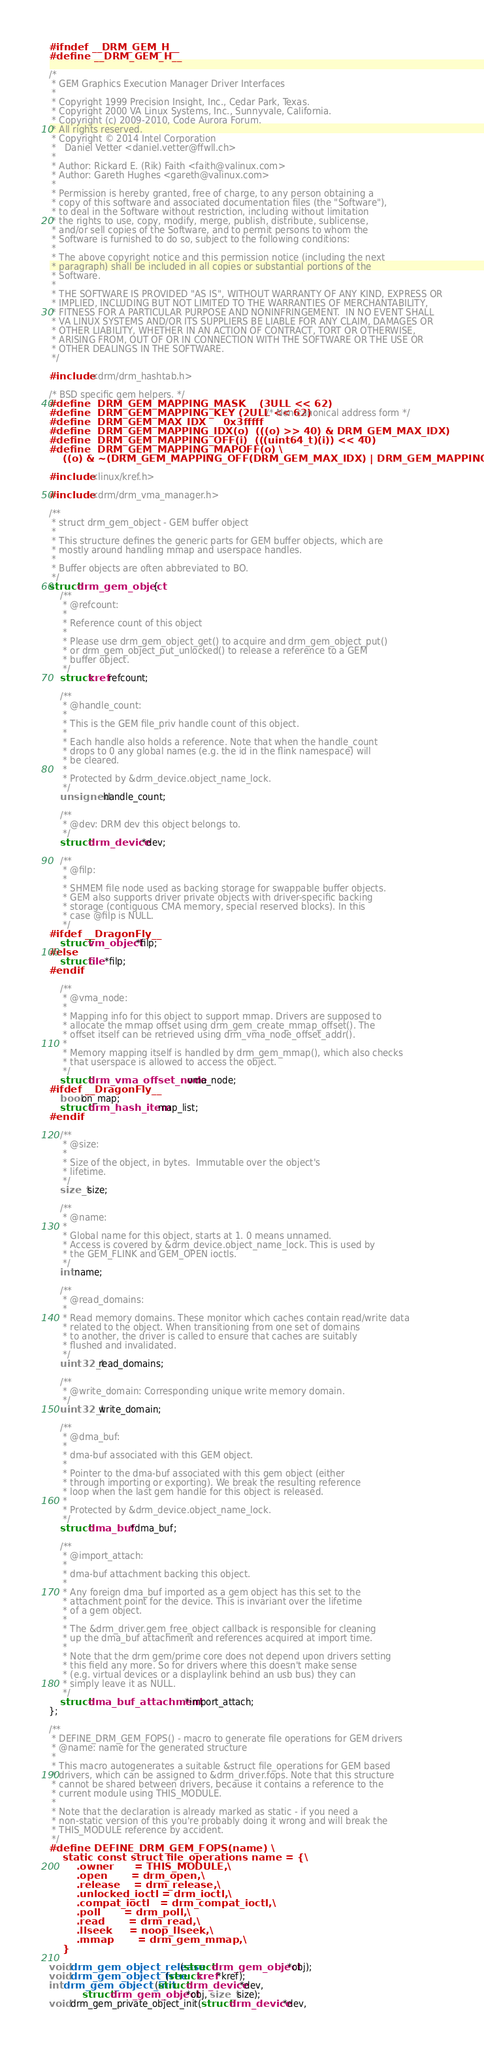<code> <loc_0><loc_0><loc_500><loc_500><_C_>#ifndef __DRM_GEM_H__
#define __DRM_GEM_H__

/*
 * GEM Graphics Execution Manager Driver Interfaces
 *
 * Copyright 1999 Precision Insight, Inc., Cedar Park, Texas.
 * Copyright 2000 VA Linux Systems, Inc., Sunnyvale, California.
 * Copyright (c) 2009-2010, Code Aurora Forum.
 * All rights reserved.
 * Copyright © 2014 Intel Corporation
 *   Daniel Vetter <daniel.vetter@ffwll.ch>
 *
 * Author: Rickard E. (Rik) Faith <faith@valinux.com>
 * Author: Gareth Hughes <gareth@valinux.com>
 *
 * Permission is hereby granted, free of charge, to any person obtaining a
 * copy of this software and associated documentation files (the "Software"),
 * to deal in the Software without restriction, including without limitation
 * the rights to use, copy, modify, merge, publish, distribute, sublicense,
 * and/or sell copies of the Software, and to permit persons to whom the
 * Software is furnished to do so, subject to the following conditions:
 *
 * The above copyright notice and this permission notice (including the next
 * paragraph) shall be included in all copies or substantial portions of the
 * Software.
 *
 * THE SOFTWARE IS PROVIDED "AS IS", WITHOUT WARRANTY OF ANY KIND, EXPRESS OR
 * IMPLIED, INCLUDING BUT NOT LIMITED TO THE WARRANTIES OF MERCHANTABILITY,
 * FITNESS FOR A PARTICULAR PURPOSE AND NONINFRINGEMENT.  IN NO EVENT SHALL
 * VA LINUX SYSTEMS AND/OR ITS SUPPLIERS BE LIABLE FOR ANY CLAIM, DAMAGES OR
 * OTHER LIABILITY, WHETHER IN AN ACTION OF CONTRACT, TORT OR OTHERWISE,
 * ARISING FROM, OUT OF OR IN CONNECTION WITH THE SOFTWARE OR THE USE OR
 * OTHER DEALINGS IN THE SOFTWARE.
 */

#include <drm/drm_hashtab.h>

/* BSD specific gem helpers. */
#define	DRM_GEM_MAPPING_MASK	(3ULL << 62)
#define	DRM_GEM_MAPPING_KEY	(2ULL << 62) /* Non-canonical address form */
#define	DRM_GEM_MAX_IDX		0x3fffff
#define	DRM_GEM_MAPPING_IDX(o)	(((o) >> 40) & DRM_GEM_MAX_IDX)
#define	DRM_GEM_MAPPING_OFF(i)	(((uint64_t)(i)) << 40)
#define	DRM_GEM_MAPPING_MAPOFF(o) \
    ((o) & ~(DRM_GEM_MAPPING_OFF(DRM_GEM_MAX_IDX) | DRM_GEM_MAPPING_KEY))

#include <linux/kref.h>

#include <drm/drm_vma_manager.h>

/**
 * struct drm_gem_object - GEM buffer object
 *
 * This structure defines the generic parts for GEM buffer objects, which are
 * mostly around handling mmap and userspace handles.
 *
 * Buffer objects are often abbreviated to BO.
 */
struct drm_gem_object {
	/**
	 * @refcount:
	 *
	 * Reference count of this object
	 *
	 * Please use drm_gem_object_get() to acquire and drm_gem_object_put()
	 * or drm_gem_object_put_unlocked() to release a reference to a GEM
	 * buffer object.
	 */
	struct kref refcount;

	/**
	 * @handle_count:
	 *
	 * This is the GEM file_priv handle count of this object.
	 *
	 * Each handle also holds a reference. Note that when the handle_count
	 * drops to 0 any global names (e.g. the id in the flink namespace) will
	 * be cleared.
	 *
	 * Protected by &drm_device.object_name_lock.
	 */
	unsigned handle_count;

	/**
	 * @dev: DRM dev this object belongs to.
	 */
	struct drm_device *dev;

	/**
	 * @filp:
	 *
	 * SHMEM file node used as backing storage for swappable buffer objects.
	 * GEM also supports driver private objects with driver-specific backing
	 * storage (contiguous CMA memory, special reserved blocks). In this
	 * case @filp is NULL.
	 */
#ifdef __DragonFly__
	struct vm_object *filp;
#else
	struct file *filp;
#endif

	/**
	 * @vma_node:
	 *
	 * Mapping info for this object to support mmap. Drivers are supposed to
	 * allocate the mmap offset using drm_gem_create_mmap_offset(). The
	 * offset itself can be retrieved using drm_vma_node_offset_addr().
	 *
	 * Memory mapping itself is handled by drm_gem_mmap(), which also checks
	 * that userspace is allowed to access the object.
	 */
	struct drm_vma_offset_node vma_node;
#ifdef __DragonFly__
	bool on_map;
	struct drm_hash_item map_list;
#endif

	/**
	 * @size:
	 *
	 * Size of the object, in bytes.  Immutable over the object's
	 * lifetime.
	 */
	size_t size;

	/**
	 * @name:
	 *
	 * Global name for this object, starts at 1. 0 means unnamed.
	 * Access is covered by &drm_device.object_name_lock. This is used by
	 * the GEM_FLINK and GEM_OPEN ioctls.
	 */
	int name;

	/**
	 * @read_domains:
	 *
	 * Read memory domains. These monitor which caches contain read/write data
	 * related to the object. When transitioning from one set of domains
	 * to another, the driver is called to ensure that caches are suitably
	 * flushed and invalidated.
	 */
	uint32_t read_domains;

	/**
	 * @write_domain: Corresponding unique write memory domain.
	 */
	uint32_t write_domain;

	/**
	 * @dma_buf:
	 *
	 * dma-buf associated with this GEM object.
	 *
	 * Pointer to the dma-buf associated with this gem object (either
	 * through importing or exporting). We break the resulting reference
	 * loop when the last gem handle for this object is released.
	 *
	 * Protected by &drm_device.object_name_lock.
	 */
	struct dma_buf *dma_buf;

	/**
	 * @import_attach:
	 *
	 * dma-buf attachment backing this object.
	 *
	 * Any foreign dma_buf imported as a gem object has this set to the
	 * attachment point for the device. This is invariant over the lifetime
	 * of a gem object.
	 *
	 * The &drm_driver.gem_free_object callback is responsible for cleaning
	 * up the dma_buf attachment and references acquired at import time.
	 *
	 * Note that the drm gem/prime core does not depend upon drivers setting
	 * this field any more. So for drivers where this doesn't make sense
	 * (e.g. virtual devices or a displaylink behind an usb bus) they can
	 * simply leave it as NULL.
	 */
	struct dma_buf_attachment *import_attach;
};

/**
 * DEFINE_DRM_GEM_FOPS() - macro to generate file operations for GEM drivers
 * @name: name for the generated structure
 *
 * This macro autogenerates a suitable &struct file_operations for GEM based
 * drivers, which can be assigned to &drm_driver.fops. Note that this structure
 * cannot be shared between drivers, because it contains a reference to the
 * current module using THIS_MODULE.
 *
 * Note that the declaration is already marked as static - if you need a
 * non-static version of this you're probably doing it wrong and will break the
 * THIS_MODULE reference by accident.
 */
#define DEFINE_DRM_GEM_FOPS(name) \
	static const struct file_operations name = {\
		.owner		= THIS_MODULE,\
		.open		= drm_open,\
		.release	= drm_release,\
		.unlocked_ioctl	= drm_ioctl,\
		.compat_ioctl	= drm_compat_ioctl,\
		.poll		= drm_poll,\
		.read		= drm_read,\
		.llseek		= noop_llseek,\
		.mmap		= drm_gem_mmap,\
	}

void drm_gem_object_release(struct drm_gem_object *obj);
void drm_gem_object_free(struct kref *kref);
int drm_gem_object_init(struct drm_device *dev,
			struct drm_gem_object *obj, size_t size);
void drm_gem_private_object_init(struct drm_device *dev,</code> 